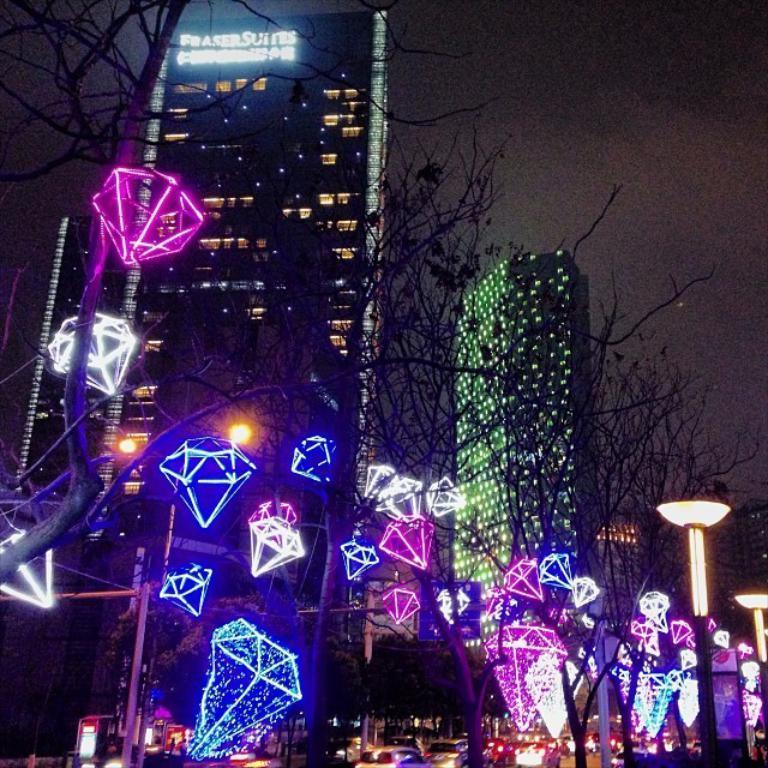Please provide a concise description of this image. In the image there are trees and there are some lights attached to those trees, behind the trees there are some vehicles on the road and in the background there are buildings. 